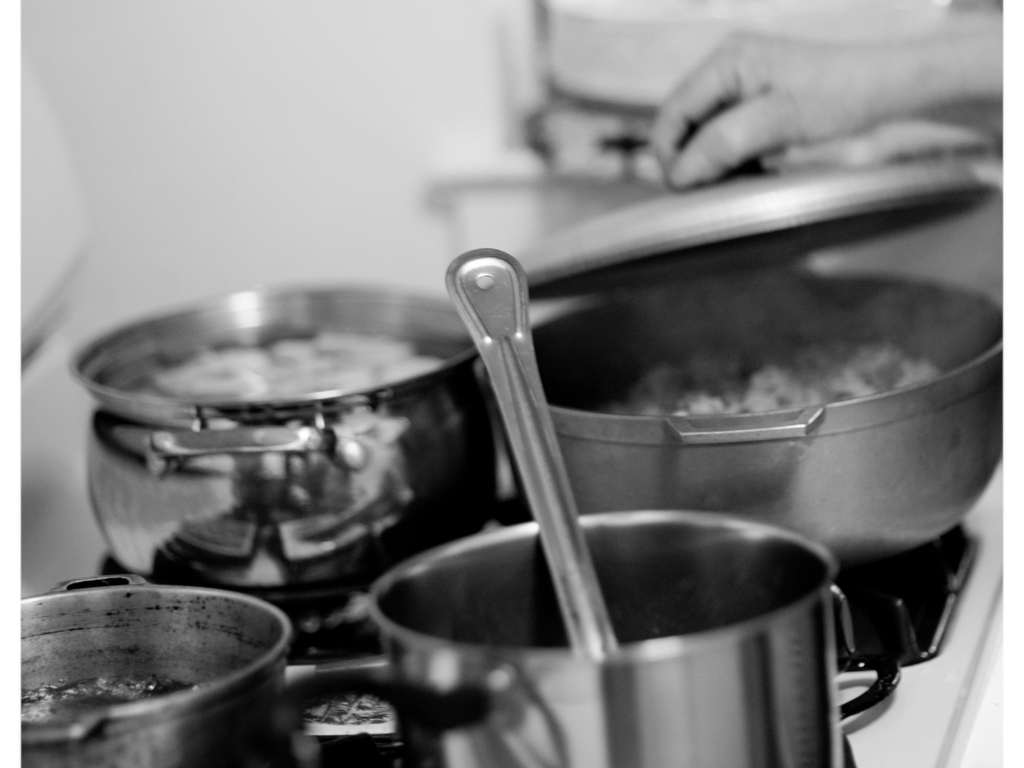How would you describe the lighting?
A. Bright
B. Dim
C. Harsh
D. Average The lighting in the image presents a soft and muted quality that permeates the scene without creating harsh shadows or overexposed areas, which aligns best with option B, Dim. 